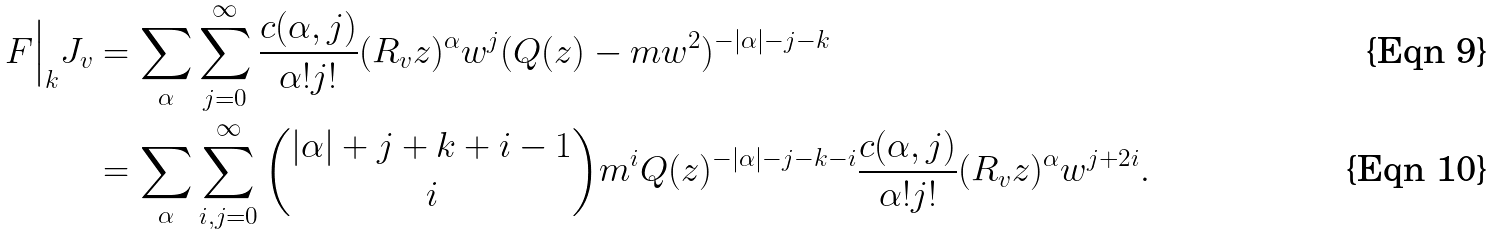<formula> <loc_0><loc_0><loc_500><loc_500>F \Big | _ { k } J _ { v } & = \sum _ { \alpha } \sum _ { j = 0 } ^ { \infty } \frac { c ( \alpha , j ) } { \alpha ! j ! } ( R _ { v } z ) ^ { \alpha } w ^ { j } ( Q ( z ) - m w ^ { 2 } ) ^ { - | \alpha | - j - k } \\ & = \sum _ { \alpha } \sum _ { i , j = 0 } ^ { \infty } \binom { | \alpha | + j + k + i - 1 } { i } m ^ { i } Q ( z ) ^ { - | \alpha | - j - k - i } \frac { c ( \alpha , j ) } { \alpha ! j ! } ( R _ { v } z ) ^ { \alpha } w ^ { j + 2 i } .</formula> 